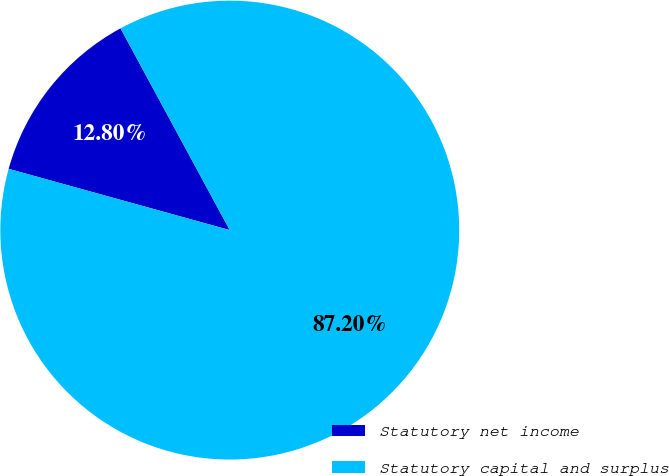<chart> <loc_0><loc_0><loc_500><loc_500><pie_chart><fcel>Statutory net income<fcel>Statutory capital and surplus<nl><fcel>12.8%<fcel>87.2%<nl></chart> 